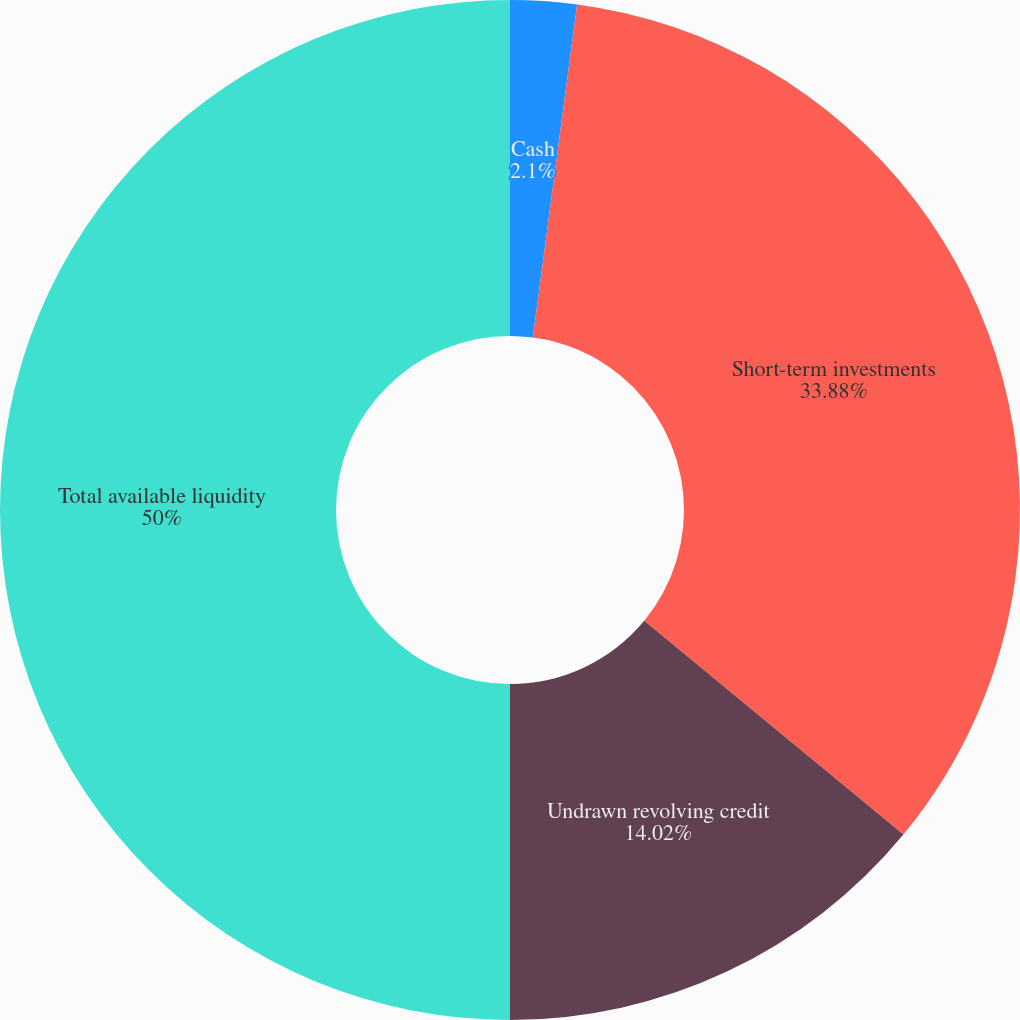Convert chart. <chart><loc_0><loc_0><loc_500><loc_500><pie_chart><fcel>Cash<fcel>Short-term investments<fcel>Undrawn revolving credit<fcel>Total available liquidity<nl><fcel>2.1%<fcel>33.88%<fcel>14.02%<fcel>50.0%<nl></chart> 